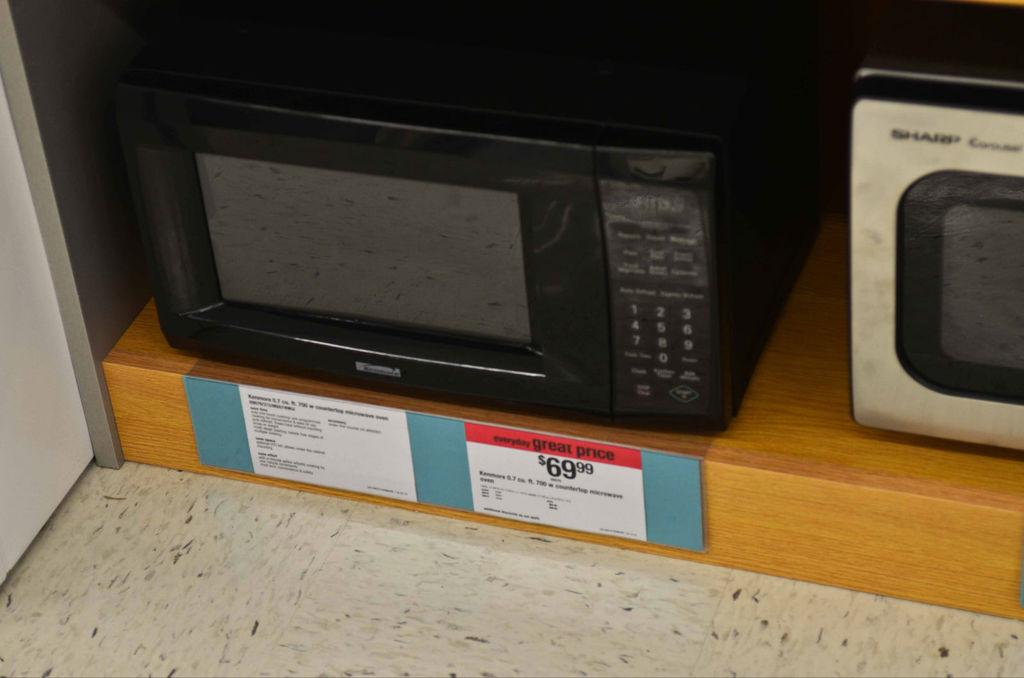<image>
Offer a succinct explanation of the picture presented. The microwave is currently priced at $69.99 which the shop considers a great price. 